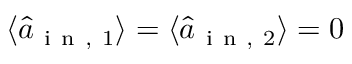Convert formula to latex. <formula><loc_0><loc_0><loc_500><loc_500>\langle \hat { a } _ { i n , 1 } \rangle = \langle \hat { a } _ { i n , 2 } \rangle = 0</formula> 